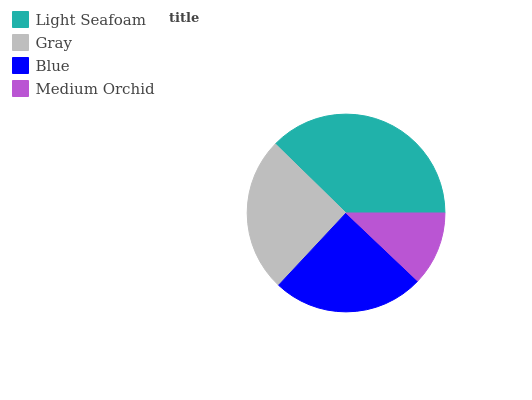Is Medium Orchid the minimum?
Answer yes or no. Yes. Is Light Seafoam the maximum?
Answer yes or no. Yes. Is Gray the minimum?
Answer yes or no. No. Is Gray the maximum?
Answer yes or no. No. Is Light Seafoam greater than Gray?
Answer yes or no. Yes. Is Gray less than Light Seafoam?
Answer yes or no. Yes. Is Gray greater than Light Seafoam?
Answer yes or no. No. Is Light Seafoam less than Gray?
Answer yes or no. No. Is Gray the high median?
Answer yes or no. Yes. Is Blue the low median?
Answer yes or no. Yes. Is Medium Orchid the high median?
Answer yes or no. No. Is Medium Orchid the low median?
Answer yes or no. No. 